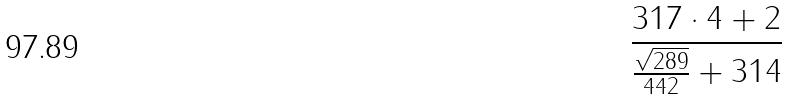Convert formula to latex. <formula><loc_0><loc_0><loc_500><loc_500>\frac { 3 1 7 \cdot 4 + 2 } { \frac { \sqrt { 2 8 9 } } { 4 4 2 } + 3 1 4 }</formula> 